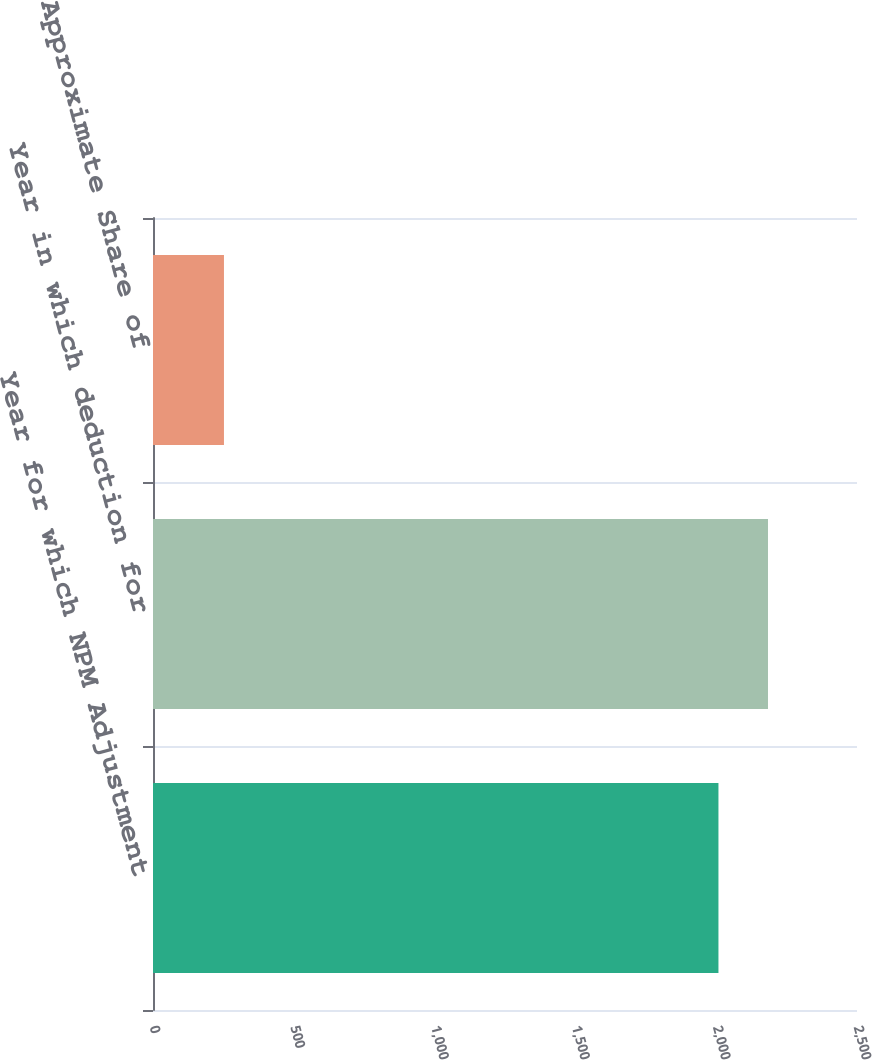Convert chart. <chart><loc_0><loc_0><loc_500><loc_500><bar_chart><fcel>Year for which NPM Adjustment<fcel>Year in which deduction for<fcel>PM USA's Approximate Share of<nl><fcel>2008<fcel>2183.9<fcel>252<nl></chart> 